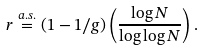<formula> <loc_0><loc_0><loc_500><loc_500>r \stackrel { a . s . } { = } ( 1 - { 1 } / { g } ) \left ( \frac { \log N } { \log \log N } \right ) .</formula> 